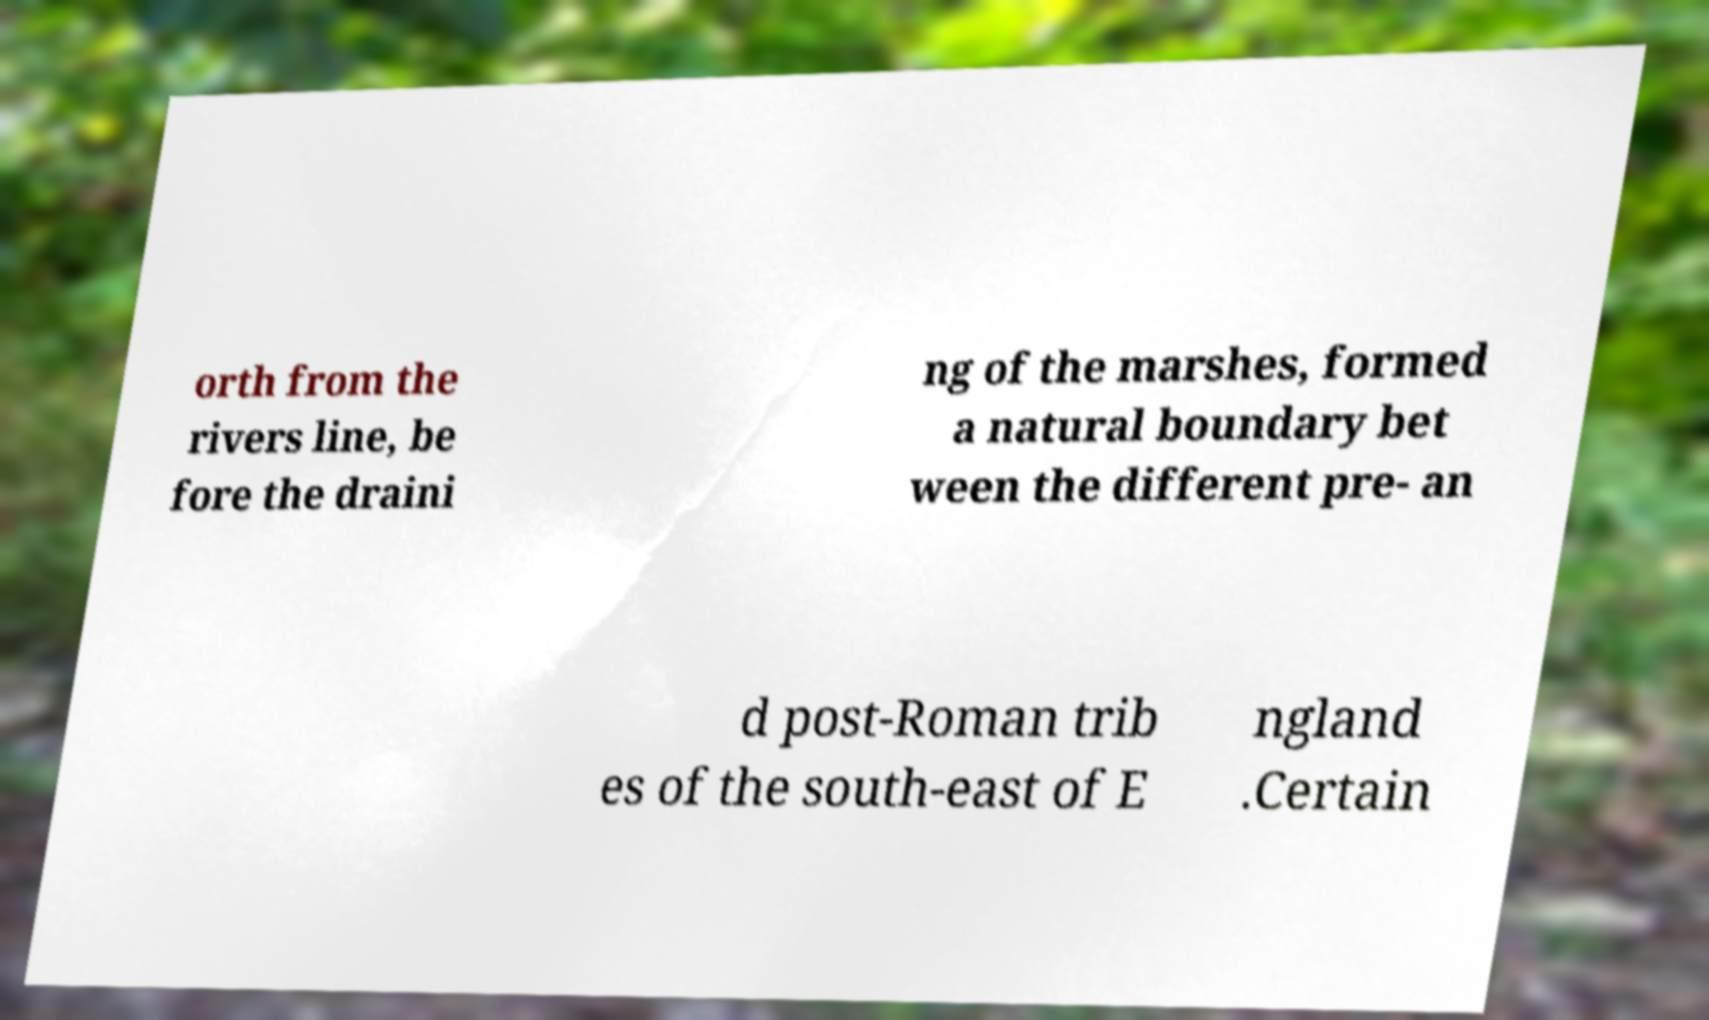There's text embedded in this image that I need extracted. Can you transcribe it verbatim? orth from the rivers line, be fore the draini ng of the marshes, formed a natural boundary bet ween the different pre- an d post-Roman trib es of the south-east of E ngland .Certain 